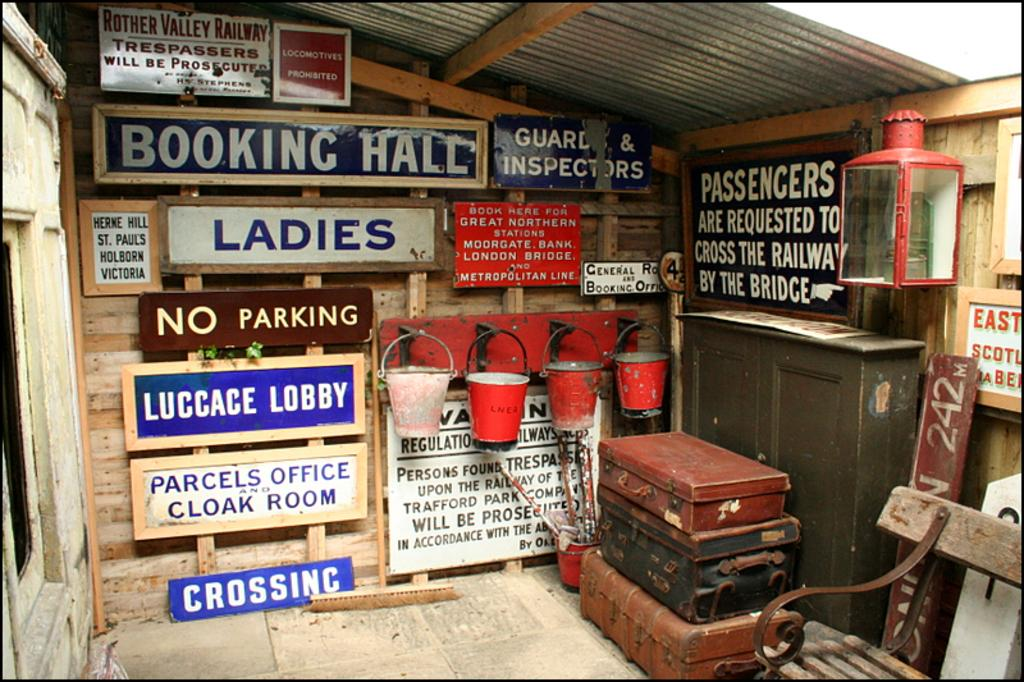What objects are on the right side of the image? There are three suitcases on the right side of the image. What is attached to the hanger in the image? There are four buckets fixed to a hanger. What type of chair is in the image? There is a wooden chair in the image. What type of structure is made of wood in the image? There are wooden hoardings in the image. What advice is given by the cent in the image? There is no cent or advice present in the image. How does the cough affect the wooden hoardings in the image? There is no cough present in the image, and the wooden hoardings are not affected by any cough. 